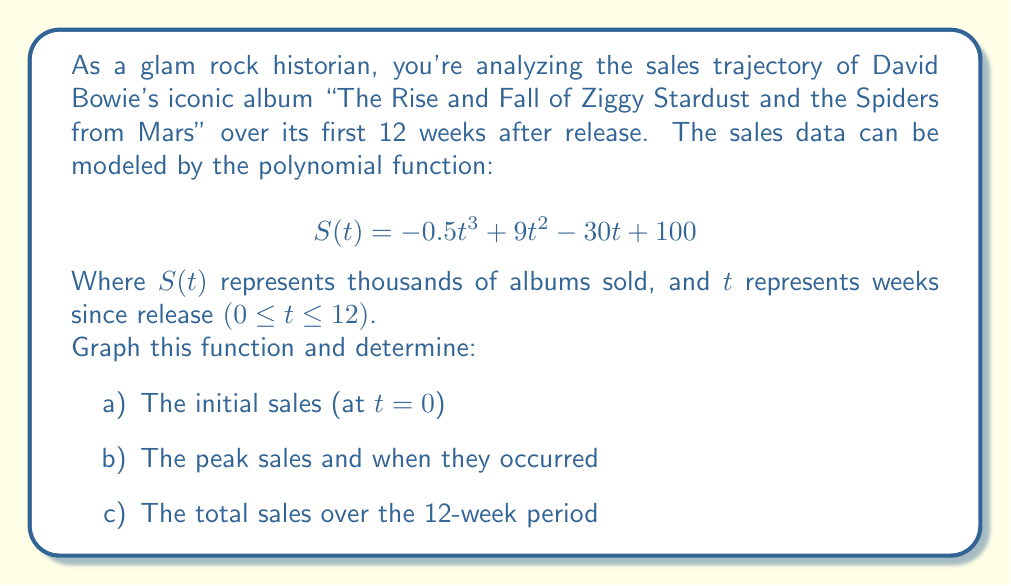Teach me how to tackle this problem. Let's approach this step-by-step:

1) To graph the function, we'll use Asymptote to plot $S(t) = -0.5t^3 + 9t^2 - 30t + 100$ for 0 ≤ t ≤ 12:

[asy]
import graph;
size(200,150);

real f(real t) {return -0.5*t^3 + 9*t^2 - 30*t + 100;}

draw(graph(f,0,12),red);

xaxis("Weeks (t)",arrow=Arrow);
yaxis("Sales in thousands (S)",arrow=Arrow);

label("S(t)",(6,f(6)),NE);
[/asy]

2) For part a, we need to find S(0):
   $$ S(0) = -0.5(0)^3 + 9(0)^2 - 30(0) + 100 = 100 $$

3) For part b, to find the peak sales, we need to find the maximum of S(t). We can do this by finding where the derivative S'(t) = 0:
   $$ S'(t) = -1.5t^2 + 18t - 30 $$
   Setting this equal to zero:
   $$ -1.5t^2 + 18t - 30 = 0 $$
   Solving this quadratic equation:
   $$ t = \frac{-18 \pm \sqrt{18^2 - 4(-1.5)(-30)}}{2(-1.5)} = 2 \text{ or } 10 $$
   The maximum occurs at t = 2 weeks.
   The peak sales are:
   $$ S(2) = -0.5(2)^3 + 9(2)^2 - 30(2) + 100 = 124 \text{ thousand albums} $$

4) For part c, to find total sales, we need to integrate S(t) from 0 to 12:
   $$ \int_0^{12} S(t) dt = \int_0^{12} (-0.5t^3 + 9t^2 - 30t + 100) dt $$
   $$ = [-0.125t^4 + 3t^3 - 15t^2 + 100t]_0^{12} $$
   $$ = (-0.125(12)^4 + 3(12)^3 - 15(12)^2 + 100(12)) - (0) = 816 $$
Answer: a) Initial sales: 100 thousand albums
b) Peak sales: 124 thousand albums, occurring 2 weeks after release
c) Total sales over 12 weeks: 816 thousand albums 